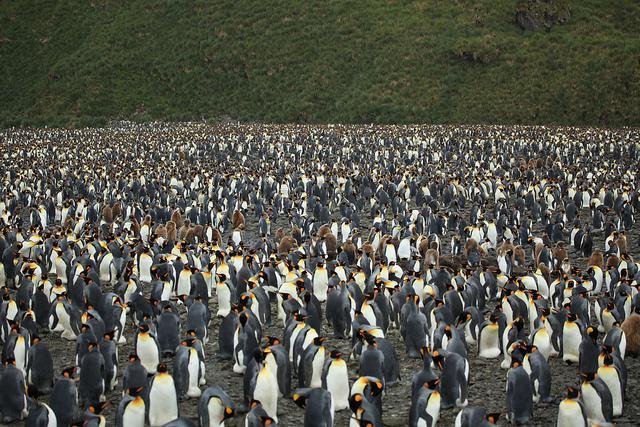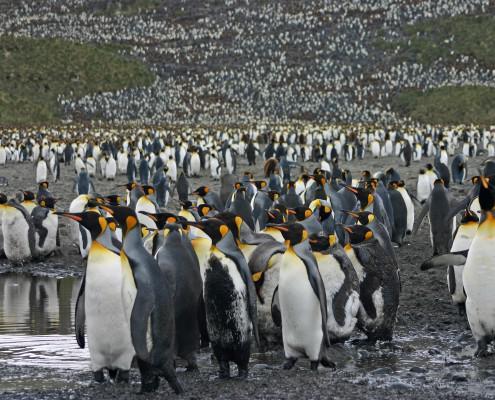The first image is the image on the left, the second image is the image on the right. For the images shown, is this caption "At least one of the images features a young penguin in brown downy feathers, at the foreground of the scene." true? Answer yes or no. No. 